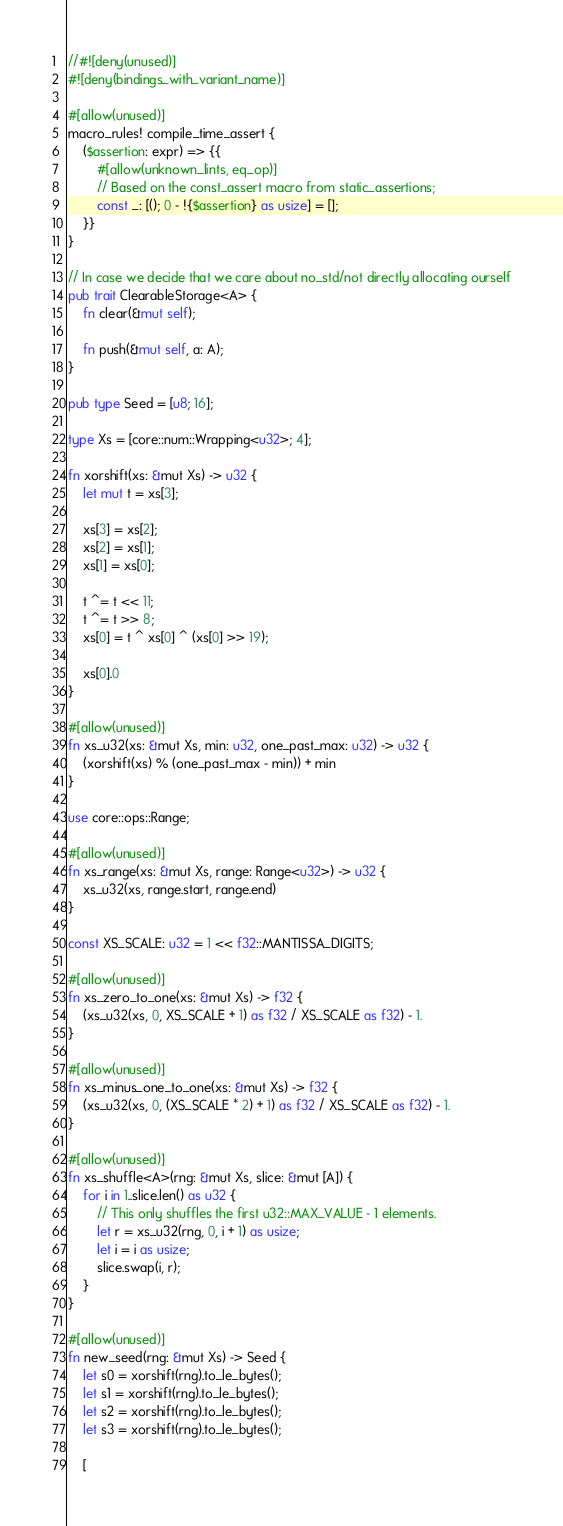Convert code to text. <code><loc_0><loc_0><loc_500><loc_500><_Rust_>//#![deny(unused)]
#![deny(bindings_with_variant_name)]

#[allow(unused)]
macro_rules! compile_time_assert {
    ($assertion: expr) => {{
        #[allow(unknown_lints, eq_op)]
        // Based on the const_assert macro from static_assertions;
        const _: [(); 0 - !{$assertion} as usize] = [];
    }}
}

// In case we decide that we care about no_std/not directly allocating ourself
pub trait ClearableStorage<A> {
    fn clear(&mut self);

    fn push(&mut self, a: A);
}

pub type Seed = [u8; 16];

type Xs = [core::num::Wrapping<u32>; 4];

fn xorshift(xs: &mut Xs) -> u32 {
    let mut t = xs[3];

    xs[3] = xs[2];
    xs[2] = xs[1];
    xs[1] = xs[0];

    t ^= t << 11;
    t ^= t >> 8;
    xs[0] = t ^ xs[0] ^ (xs[0] >> 19);

    xs[0].0
}

#[allow(unused)]
fn xs_u32(xs: &mut Xs, min: u32, one_past_max: u32) -> u32 {
    (xorshift(xs) % (one_past_max - min)) + min
}

use core::ops::Range;

#[allow(unused)]
fn xs_range(xs: &mut Xs, range: Range<u32>) -> u32 {
    xs_u32(xs, range.start, range.end)
}

const XS_SCALE: u32 = 1 << f32::MANTISSA_DIGITS;

#[allow(unused)]
fn xs_zero_to_one(xs: &mut Xs) -> f32 {
    (xs_u32(xs, 0, XS_SCALE + 1) as f32 / XS_SCALE as f32) - 1.
}

#[allow(unused)]
fn xs_minus_one_to_one(xs: &mut Xs) -> f32 {
    (xs_u32(xs, 0, (XS_SCALE * 2) + 1) as f32 / XS_SCALE as f32) - 1.
}

#[allow(unused)]
fn xs_shuffle<A>(rng: &mut Xs, slice: &mut [A]) {
    for i in 1..slice.len() as u32 {
        // This only shuffles the first u32::MAX_VALUE - 1 elements.
        let r = xs_u32(rng, 0, i + 1) as usize;
        let i = i as usize;
        slice.swap(i, r);
    }
}

#[allow(unused)]
fn new_seed(rng: &mut Xs) -> Seed {
    let s0 = xorshift(rng).to_le_bytes();
    let s1 = xorshift(rng).to_le_bytes();
    let s2 = xorshift(rng).to_le_bytes();
    let s3 = xorshift(rng).to_le_bytes();

    [</code> 